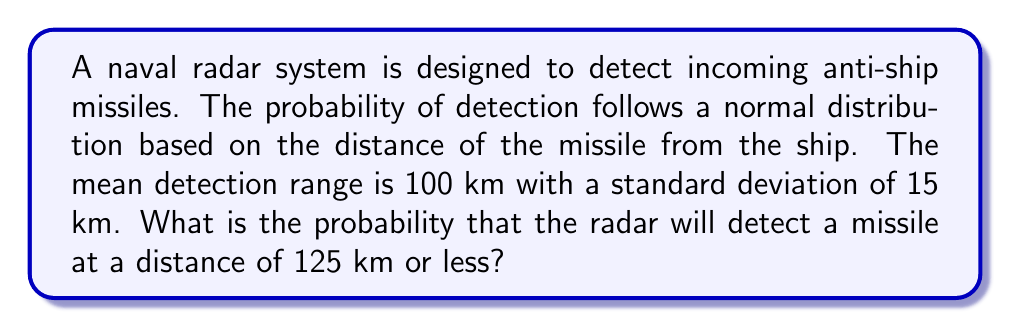Show me your answer to this math problem. To solve this problem, we need to use the properties of the normal distribution and calculate the z-score for the given distance.

1. Given information:
   - Mean detection range (μ) = 100 km
   - Standard deviation (σ) = 15 km
   - Distance of interest (x) = 125 km

2. Calculate the z-score:
   The z-score represents how many standard deviations the given value is from the mean.
   $$z = \frac{x - μ}{σ} = \frac{125 - 100}{15} = \frac{25}{15} ≈ 1.67$$

3. Use the standard normal distribution table or a calculator to find the probability:
   We need to find P(X ≤ 125), which is equivalent to P(Z ≤ 1.67) in the standard normal distribution.

4. Using a standard normal distribution table or calculator, we find:
   P(Z ≤ 1.67) ≈ 0.9525

5. Convert to percentage:
   0.9525 * 100 = 95.25%

Therefore, the probability that the radar will detect a missile at a distance of 125 km or less is approximately 95.25%.
Answer: The probability that the radar will detect a missile at a distance of 125 km or less is approximately 95.25%. 